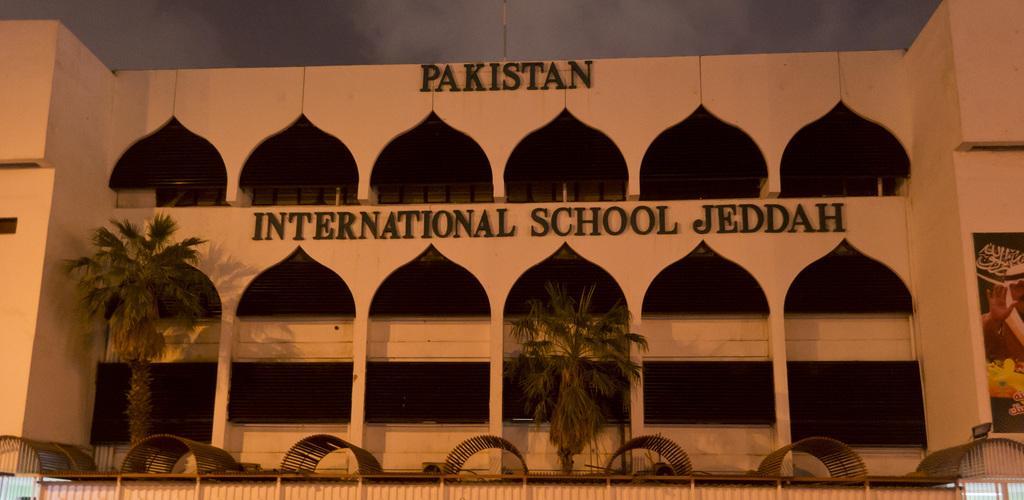How would you summarize this image in a sentence or two? In the center of the image there is a building, trees. In the background we can see sky and clouds. 